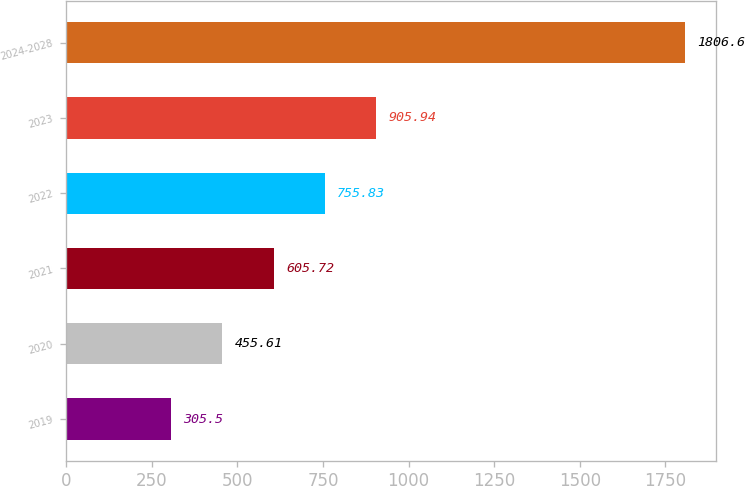Convert chart to OTSL. <chart><loc_0><loc_0><loc_500><loc_500><bar_chart><fcel>2019<fcel>2020<fcel>2021<fcel>2022<fcel>2023<fcel>2024-2028<nl><fcel>305.5<fcel>455.61<fcel>605.72<fcel>755.83<fcel>905.94<fcel>1806.6<nl></chart> 